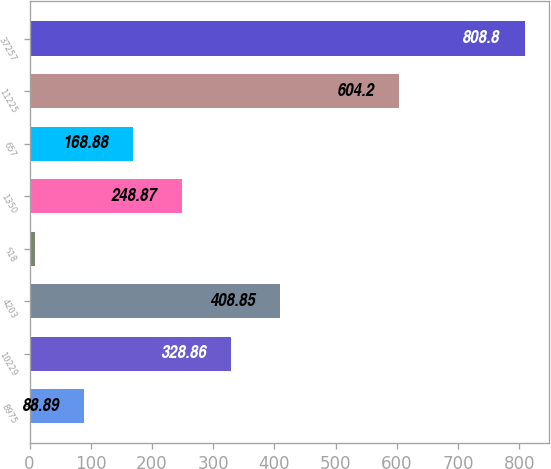<chart> <loc_0><loc_0><loc_500><loc_500><bar_chart><fcel>8975<fcel>10229<fcel>4203<fcel>618<fcel>1350<fcel>657<fcel>11225<fcel>37257<nl><fcel>88.89<fcel>328.86<fcel>408.85<fcel>8.9<fcel>248.87<fcel>168.88<fcel>604.2<fcel>808.8<nl></chart> 